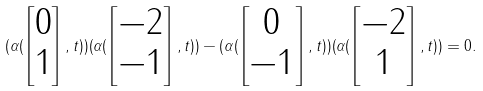<formula> <loc_0><loc_0><loc_500><loc_500>( \alpha ( \begin{bmatrix} 0 \\ 1 \end{bmatrix} , t ) ) ( \alpha ( \begin{bmatrix} - 2 \\ - 1 \end{bmatrix} , t ) ) - ( \alpha ( \begin{bmatrix} 0 \\ - 1 \end{bmatrix} , t ) ) ( \alpha ( \begin{bmatrix} - 2 \\ 1 \end{bmatrix} , t ) ) = 0 .</formula> 